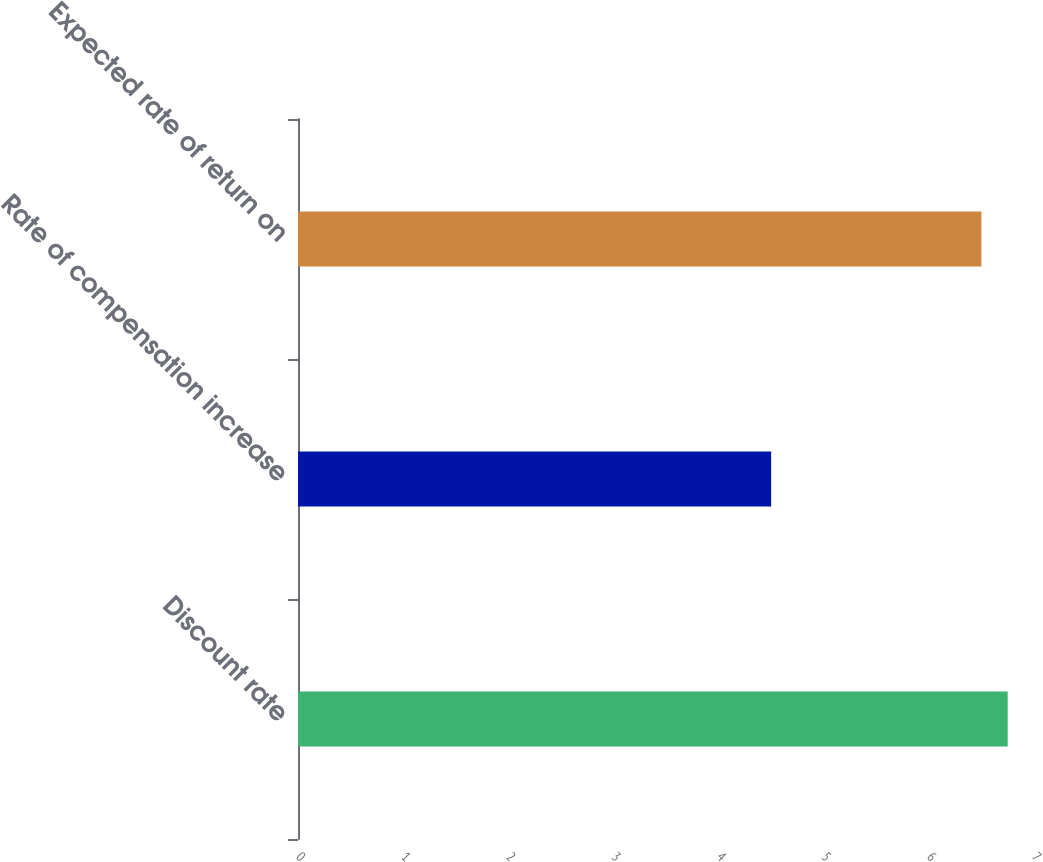Convert chart to OTSL. <chart><loc_0><loc_0><loc_500><loc_500><bar_chart><fcel>Discount rate<fcel>Rate of compensation increase<fcel>Expected rate of return on<nl><fcel>6.75<fcel>4.5<fcel>6.5<nl></chart> 